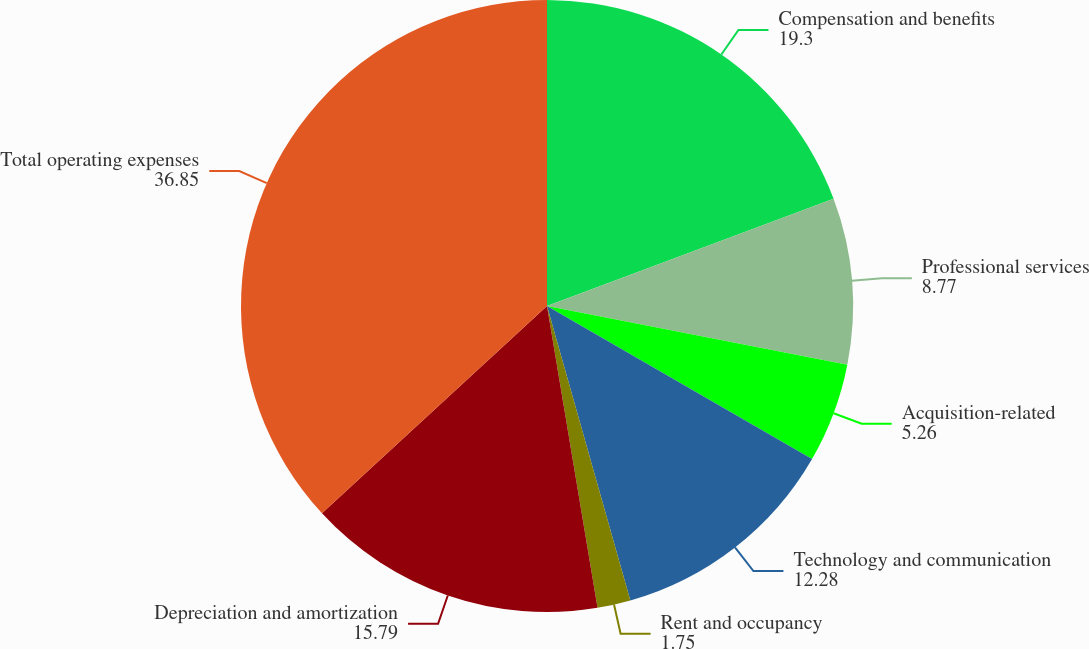Convert chart to OTSL. <chart><loc_0><loc_0><loc_500><loc_500><pie_chart><fcel>Compensation and benefits<fcel>Professional services<fcel>Acquisition-related<fcel>Technology and communication<fcel>Rent and occupancy<fcel>Depreciation and amortization<fcel>Total operating expenses<nl><fcel>19.3%<fcel>8.77%<fcel>5.26%<fcel>12.28%<fcel>1.75%<fcel>15.79%<fcel>36.85%<nl></chart> 